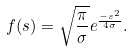<formula> <loc_0><loc_0><loc_500><loc_500>f ( s ) = \sqrt { \frac { \pi } { \sigma } } e ^ { \frac { - s ^ { 2 } } { 4 \sigma } } .</formula> 